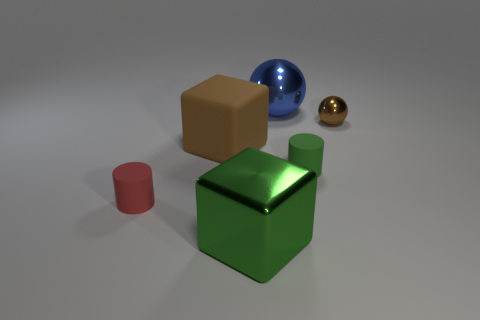Add 2 tiny red objects. How many objects exist? 8 Subtract all balls. How many objects are left? 4 Subtract 1 green cylinders. How many objects are left? 5 Subtract all tiny green cylinders. Subtract all green metal things. How many objects are left? 4 Add 6 small spheres. How many small spheres are left? 7 Add 2 green metallic cubes. How many green metallic cubes exist? 3 